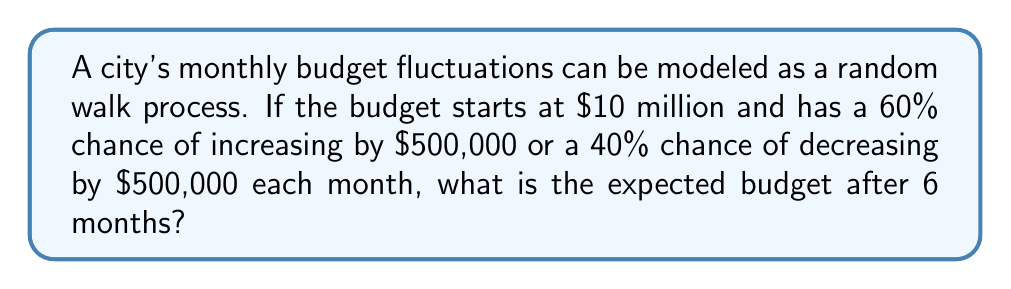Teach me how to tackle this problem. Let's approach this step-by-step:

1) In a random walk process, the expected change at each step is:

   $E[\text{change}] = p(\text{increase}) \cdot \text{increase amount} + p(\text{decrease}) \cdot \text{decrease amount}$

2) In this case:
   $E[\text{change}] = 0.6 \cdot 500,000 + 0.4 \cdot (-500,000) = 300,000 - 200,000 = 100,000$

3) The expected change per month is $100,000.

4) Over 6 months, the expected total change is:

   $E[\text{total change}] = 6 \cdot 100,000 = 600,000$

5) The initial budget is $10 million. After 6 months, the expected budget would be:

   $E[\text{final budget}] = 10,000,000 + 600,000 = 10,600,000$

Therefore, the expected budget after 6 months is $10.6 million.
Answer: $10.6 million 